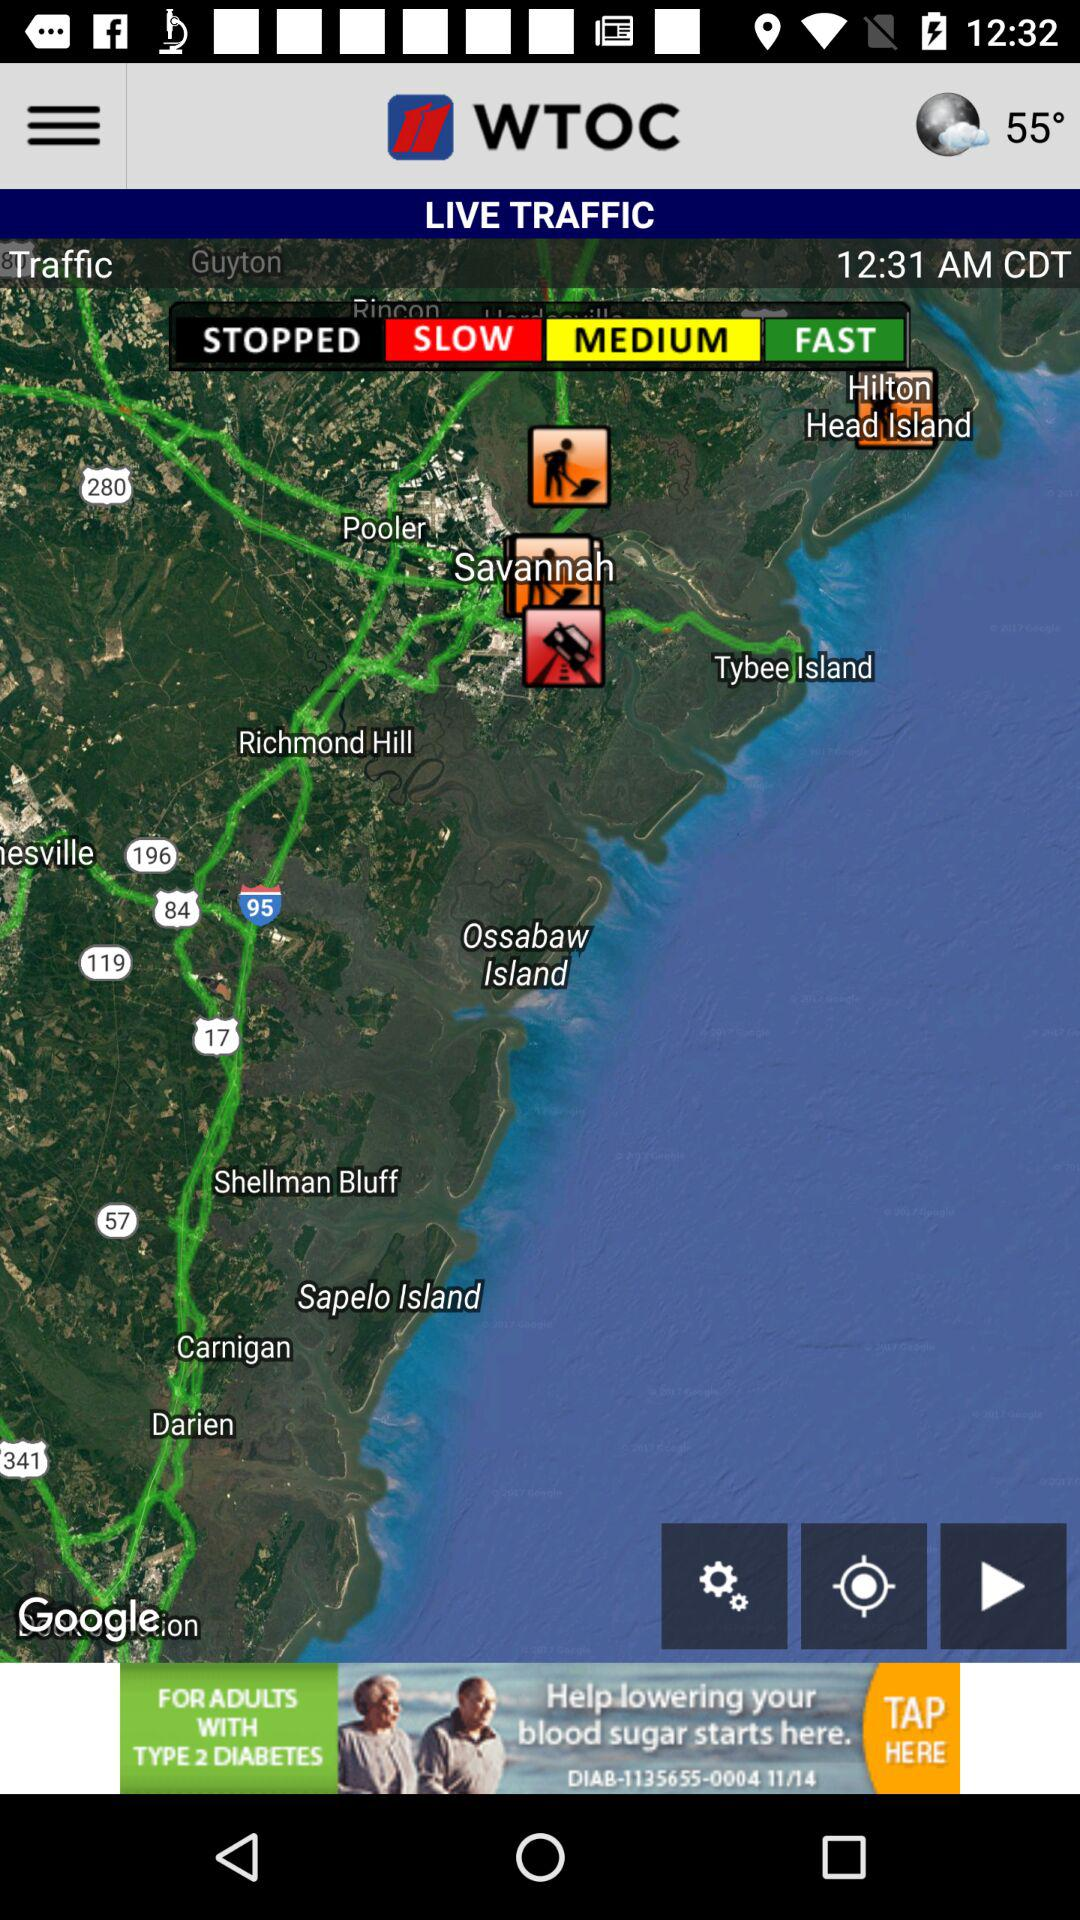What is the temperature shown on the screen? The temperature shown on the screen is 55 degrees. 